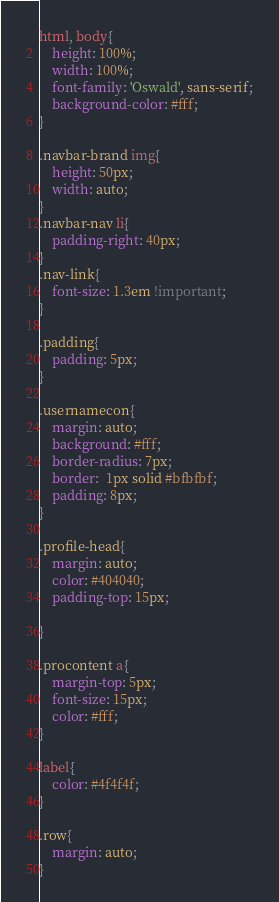Convert code to text. <code><loc_0><loc_0><loc_500><loc_500><_CSS_>html, body{
	height: 100%;
	width: 100%;
	font-family: 'Oswald', sans-serif;
	background-color: #fff;
}

.navbar-brand img{
	height: 50px;
	width: auto;
}
.navbar-nav li{
	padding-right: 40px;
}
.nav-link{
	font-size: 1.3em !important;
}

.padding{
	padding: 5px;
}

.usernamecon{
	margin: auto;
	background: #fff;
	border-radius: 7px;
	border:  1px solid #bfbfbf;
	padding: 8px;
}

.profile-head{
	margin: auto;
	color: #404040;
	padding-top: 15px;

}

.procontent a{
	margin-top: 5px;
 	font-size: 15px;
 	color: #fff;
}

label{
	color: #4f4f4f;
}

.row{
	margin: auto;
}</code> 